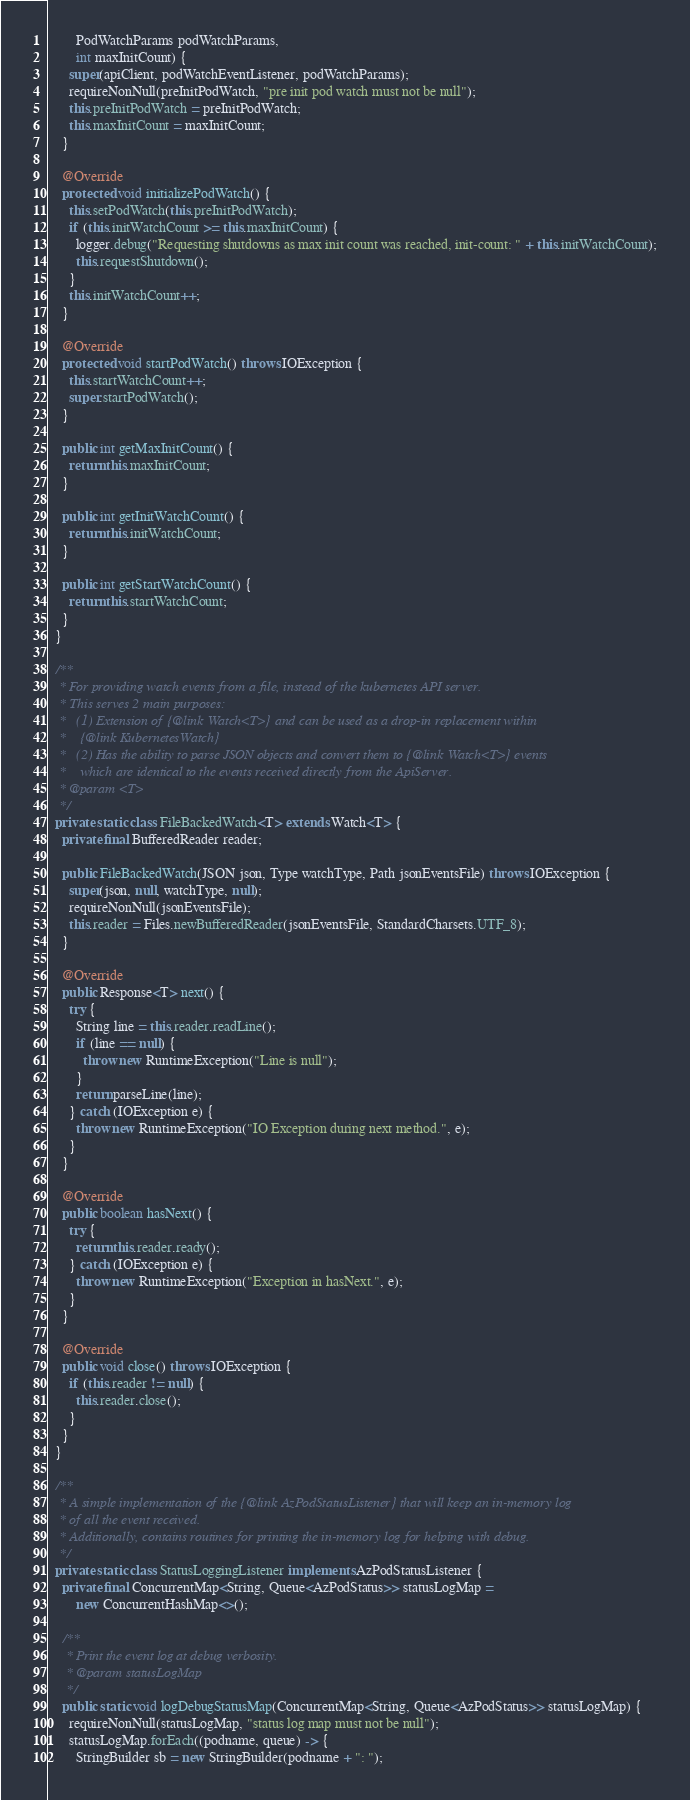Convert code to text. <code><loc_0><loc_0><loc_500><loc_500><_Java_>        PodWatchParams podWatchParams,
        int maxInitCount) {
      super(apiClient, podWatchEventListener, podWatchParams);
      requireNonNull(preInitPodWatch, "pre init pod watch must not be null");
      this.preInitPodWatch = preInitPodWatch;
      this.maxInitCount = maxInitCount;
    }

    @Override
    protected void initializePodWatch() {
      this.setPodWatch(this.preInitPodWatch);
      if (this.initWatchCount >= this.maxInitCount) {
        logger.debug("Requesting shutdowns as max init count was reached, init-count: " + this.initWatchCount);
        this.requestShutdown();
      }
      this.initWatchCount++;
    }

    @Override
    protected void startPodWatch() throws IOException {
      this.startWatchCount++;
      super.startPodWatch();
    }

    public int getMaxInitCount() {
      return this.maxInitCount;
    }

    public int getInitWatchCount() {
      return this.initWatchCount;
    }

    public int getStartWatchCount() {
      return this.startWatchCount;
    }
  }

  /**
   * For providing watch events from a file, instead of the kubernetes API server.
   * This serves 2 main purposes:
   *   (1) Extension of {@link Watch<T>} and can be used as a drop-in replacement within
   *    {@link KubernetesWatch}
   *   (2) Has the ability to parse JSON objects and convert them to {@link Watch<T>} events
   *    which are identical to the events received directly from the ApiServer.
   * @param <T>
   */
  private static class FileBackedWatch<T> extends Watch<T> {
    private final BufferedReader reader;

    public FileBackedWatch(JSON json, Type watchType, Path jsonEventsFile) throws IOException {
      super(json, null, watchType, null);
      requireNonNull(jsonEventsFile);
      this.reader = Files.newBufferedReader(jsonEventsFile, StandardCharsets.UTF_8);
    }

    @Override
    public Response<T> next() {
      try {
        String line = this.reader.readLine();
        if (line == null) {
          throw new RuntimeException("Line is null");
        }
        return parseLine(line);
      } catch (IOException e) {
        throw new RuntimeException("IO Exception during next method.", e);
      }
    }

    @Override
    public boolean hasNext() {
      try {
        return this.reader.ready();
      } catch (IOException e) {
        throw new RuntimeException("Exception in hasNext.", e);
      }
    }

    @Override
    public void close() throws IOException {
      if (this.reader != null) {
        this.reader.close();
      }
    }
  }

  /**
   * A simple implementation of the {@link AzPodStatusListener} that will keep an in-memory log
   * of all the event received.
   * Additionally, contains routines for printing the in-memory log for helping with debug.
   */
  private static class StatusLoggingListener implements AzPodStatusListener {
    private final ConcurrentMap<String, Queue<AzPodStatus>> statusLogMap =
        new ConcurrentHashMap<>();

    /**
     * Print the event log at debug verbosity.
     * @param statusLogMap
     */
    public static void logDebugStatusMap(ConcurrentMap<String, Queue<AzPodStatus>> statusLogMap) {
      requireNonNull(statusLogMap, "status log map must not be null");
      statusLogMap.forEach((podname, queue) -> {
        StringBuilder sb = new StringBuilder(podname + ": ");</code> 